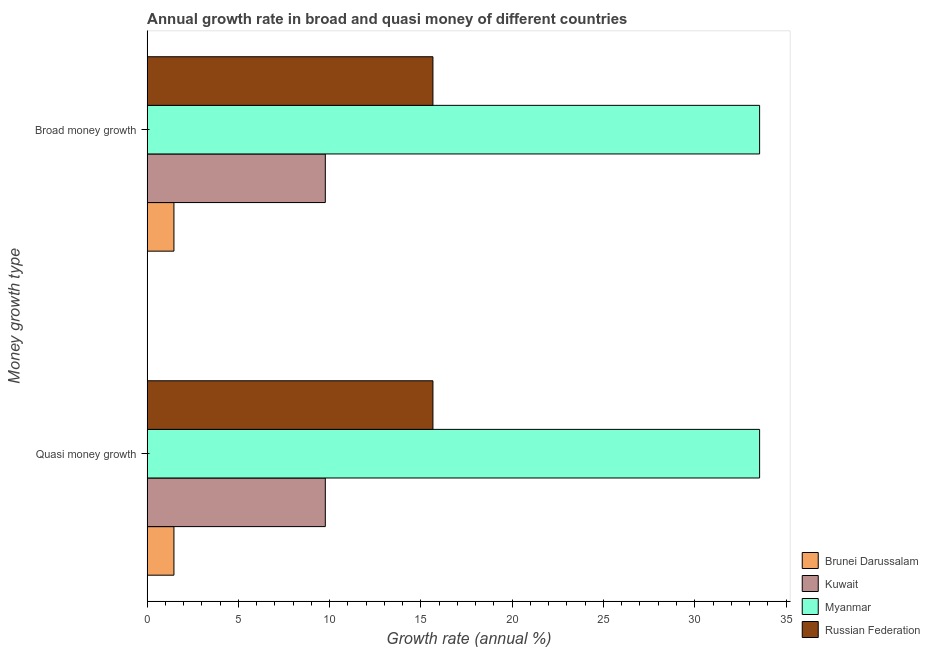How many bars are there on the 2nd tick from the top?
Your answer should be compact. 4. What is the label of the 2nd group of bars from the top?
Offer a very short reply. Quasi money growth. What is the annual growth rate in broad money in Russian Federation?
Ensure brevity in your answer.  15.66. Across all countries, what is the maximum annual growth rate in quasi money?
Offer a terse response. 33.55. Across all countries, what is the minimum annual growth rate in quasi money?
Offer a terse response. 1.47. In which country was the annual growth rate in quasi money maximum?
Give a very brief answer. Myanmar. In which country was the annual growth rate in quasi money minimum?
Your answer should be compact. Brunei Darussalam. What is the total annual growth rate in quasi money in the graph?
Give a very brief answer. 60.44. What is the difference between the annual growth rate in broad money in Russian Federation and that in Brunei Darussalam?
Give a very brief answer. 14.19. What is the difference between the annual growth rate in quasi money in Myanmar and the annual growth rate in broad money in Russian Federation?
Give a very brief answer. 17.9. What is the average annual growth rate in quasi money per country?
Provide a short and direct response. 15.11. What is the difference between the annual growth rate in broad money and annual growth rate in quasi money in Brunei Darussalam?
Offer a terse response. 0. What is the ratio of the annual growth rate in quasi money in Russian Federation to that in Kuwait?
Ensure brevity in your answer.  1.6. In how many countries, is the annual growth rate in quasi money greater than the average annual growth rate in quasi money taken over all countries?
Your answer should be compact. 2. What does the 2nd bar from the top in Broad money growth represents?
Give a very brief answer. Myanmar. What does the 1st bar from the bottom in Broad money growth represents?
Give a very brief answer. Brunei Darussalam. How many countries are there in the graph?
Ensure brevity in your answer.  4. Are the values on the major ticks of X-axis written in scientific E-notation?
Your answer should be very brief. No. Does the graph contain any zero values?
Keep it short and to the point. No. Where does the legend appear in the graph?
Make the answer very short. Bottom right. How are the legend labels stacked?
Provide a succinct answer. Vertical. What is the title of the graph?
Ensure brevity in your answer.  Annual growth rate in broad and quasi money of different countries. What is the label or title of the X-axis?
Ensure brevity in your answer.  Growth rate (annual %). What is the label or title of the Y-axis?
Keep it short and to the point. Money growth type. What is the Growth rate (annual %) in Brunei Darussalam in Quasi money growth?
Offer a terse response. 1.47. What is the Growth rate (annual %) in Kuwait in Quasi money growth?
Your answer should be compact. 9.76. What is the Growth rate (annual %) of Myanmar in Quasi money growth?
Make the answer very short. 33.55. What is the Growth rate (annual %) of Russian Federation in Quasi money growth?
Your answer should be compact. 15.66. What is the Growth rate (annual %) of Brunei Darussalam in Broad money growth?
Offer a terse response. 1.47. What is the Growth rate (annual %) in Kuwait in Broad money growth?
Your response must be concise. 9.76. What is the Growth rate (annual %) in Myanmar in Broad money growth?
Ensure brevity in your answer.  33.55. What is the Growth rate (annual %) in Russian Federation in Broad money growth?
Your answer should be compact. 15.66. Across all Money growth type, what is the maximum Growth rate (annual %) in Brunei Darussalam?
Keep it short and to the point. 1.47. Across all Money growth type, what is the maximum Growth rate (annual %) of Kuwait?
Your answer should be very brief. 9.76. Across all Money growth type, what is the maximum Growth rate (annual %) of Myanmar?
Your response must be concise. 33.55. Across all Money growth type, what is the maximum Growth rate (annual %) in Russian Federation?
Offer a terse response. 15.66. Across all Money growth type, what is the minimum Growth rate (annual %) of Brunei Darussalam?
Provide a succinct answer. 1.47. Across all Money growth type, what is the minimum Growth rate (annual %) in Kuwait?
Ensure brevity in your answer.  9.76. Across all Money growth type, what is the minimum Growth rate (annual %) in Myanmar?
Make the answer very short. 33.55. Across all Money growth type, what is the minimum Growth rate (annual %) in Russian Federation?
Make the answer very short. 15.66. What is the total Growth rate (annual %) in Brunei Darussalam in the graph?
Offer a very short reply. 2.93. What is the total Growth rate (annual %) of Kuwait in the graph?
Your answer should be very brief. 19.52. What is the total Growth rate (annual %) in Myanmar in the graph?
Your response must be concise. 67.11. What is the total Growth rate (annual %) in Russian Federation in the graph?
Provide a short and direct response. 31.31. What is the difference between the Growth rate (annual %) of Brunei Darussalam in Quasi money growth and that in Broad money growth?
Provide a short and direct response. 0. What is the difference between the Growth rate (annual %) of Kuwait in Quasi money growth and that in Broad money growth?
Your answer should be very brief. 0. What is the difference between the Growth rate (annual %) of Russian Federation in Quasi money growth and that in Broad money growth?
Keep it short and to the point. 0. What is the difference between the Growth rate (annual %) of Brunei Darussalam in Quasi money growth and the Growth rate (annual %) of Kuwait in Broad money growth?
Give a very brief answer. -8.29. What is the difference between the Growth rate (annual %) of Brunei Darussalam in Quasi money growth and the Growth rate (annual %) of Myanmar in Broad money growth?
Give a very brief answer. -32.09. What is the difference between the Growth rate (annual %) in Brunei Darussalam in Quasi money growth and the Growth rate (annual %) in Russian Federation in Broad money growth?
Make the answer very short. -14.19. What is the difference between the Growth rate (annual %) of Kuwait in Quasi money growth and the Growth rate (annual %) of Myanmar in Broad money growth?
Give a very brief answer. -23.79. What is the difference between the Growth rate (annual %) in Kuwait in Quasi money growth and the Growth rate (annual %) in Russian Federation in Broad money growth?
Offer a very short reply. -5.9. What is the difference between the Growth rate (annual %) of Myanmar in Quasi money growth and the Growth rate (annual %) of Russian Federation in Broad money growth?
Make the answer very short. 17.9. What is the average Growth rate (annual %) of Brunei Darussalam per Money growth type?
Your response must be concise. 1.47. What is the average Growth rate (annual %) in Kuwait per Money growth type?
Provide a short and direct response. 9.76. What is the average Growth rate (annual %) of Myanmar per Money growth type?
Keep it short and to the point. 33.55. What is the average Growth rate (annual %) in Russian Federation per Money growth type?
Your answer should be very brief. 15.66. What is the difference between the Growth rate (annual %) in Brunei Darussalam and Growth rate (annual %) in Kuwait in Quasi money growth?
Offer a terse response. -8.29. What is the difference between the Growth rate (annual %) in Brunei Darussalam and Growth rate (annual %) in Myanmar in Quasi money growth?
Make the answer very short. -32.09. What is the difference between the Growth rate (annual %) in Brunei Darussalam and Growth rate (annual %) in Russian Federation in Quasi money growth?
Your answer should be very brief. -14.19. What is the difference between the Growth rate (annual %) in Kuwait and Growth rate (annual %) in Myanmar in Quasi money growth?
Offer a very short reply. -23.79. What is the difference between the Growth rate (annual %) of Kuwait and Growth rate (annual %) of Russian Federation in Quasi money growth?
Ensure brevity in your answer.  -5.9. What is the difference between the Growth rate (annual %) of Myanmar and Growth rate (annual %) of Russian Federation in Quasi money growth?
Offer a very short reply. 17.9. What is the difference between the Growth rate (annual %) in Brunei Darussalam and Growth rate (annual %) in Kuwait in Broad money growth?
Give a very brief answer. -8.29. What is the difference between the Growth rate (annual %) of Brunei Darussalam and Growth rate (annual %) of Myanmar in Broad money growth?
Provide a short and direct response. -32.09. What is the difference between the Growth rate (annual %) in Brunei Darussalam and Growth rate (annual %) in Russian Federation in Broad money growth?
Provide a succinct answer. -14.19. What is the difference between the Growth rate (annual %) in Kuwait and Growth rate (annual %) in Myanmar in Broad money growth?
Your answer should be compact. -23.79. What is the difference between the Growth rate (annual %) of Kuwait and Growth rate (annual %) of Russian Federation in Broad money growth?
Your response must be concise. -5.9. What is the difference between the Growth rate (annual %) of Myanmar and Growth rate (annual %) of Russian Federation in Broad money growth?
Make the answer very short. 17.9. What is the ratio of the Growth rate (annual %) in Brunei Darussalam in Quasi money growth to that in Broad money growth?
Offer a terse response. 1. What is the ratio of the Growth rate (annual %) in Myanmar in Quasi money growth to that in Broad money growth?
Your answer should be very brief. 1. What is the ratio of the Growth rate (annual %) of Russian Federation in Quasi money growth to that in Broad money growth?
Provide a short and direct response. 1. What is the difference between the highest and the second highest Growth rate (annual %) of Kuwait?
Offer a very short reply. 0. What is the difference between the highest and the lowest Growth rate (annual %) in Brunei Darussalam?
Keep it short and to the point. 0. What is the difference between the highest and the lowest Growth rate (annual %) in Kuwait?
Make the answer very short. 0. What is the difference between the highest and the lowest Growth rate (annual %) of Myanmar?
Ensure brevity in your answer.  0. 